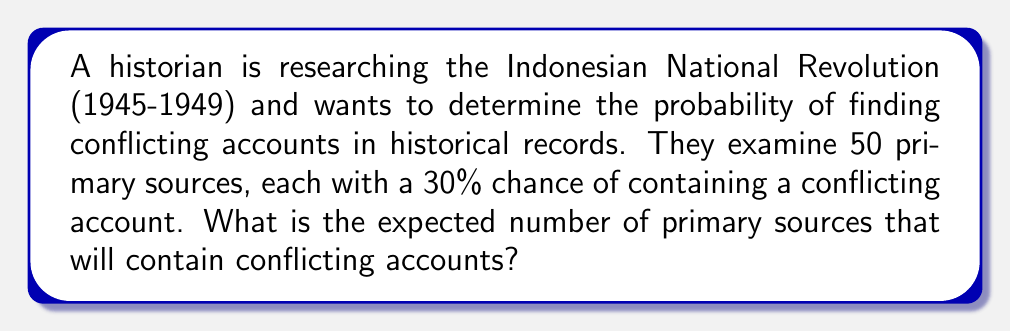What is the answer to this math problem? To solve this problem, we need to use the concept of expected value. The expected value is calculated by multiplying the probability of an event occurring by the number of trials.

Step 1: Identify the given information
- Number of primary sources (n) = 50
- Probability of a source containing a conflicting account (p) = 30% = 0.3

Step 2: Calculate the expected value
The expected value formula is:

$$ E(X) = n \times p $$

Where:
$E(X)$ is the expected value
$n$ is the number of trials (primary sources)
$p$ is the probability of success (containing a conflicting account)

Substituting the values:

$$ E(X) = 50 \times 0.3 $$

Step 3: Compute the final result

$$ E(X) = 15 $$

Therefore, the expected number of primary sources containing conflicting accounts is 15.
Answer: 15 primary sources 